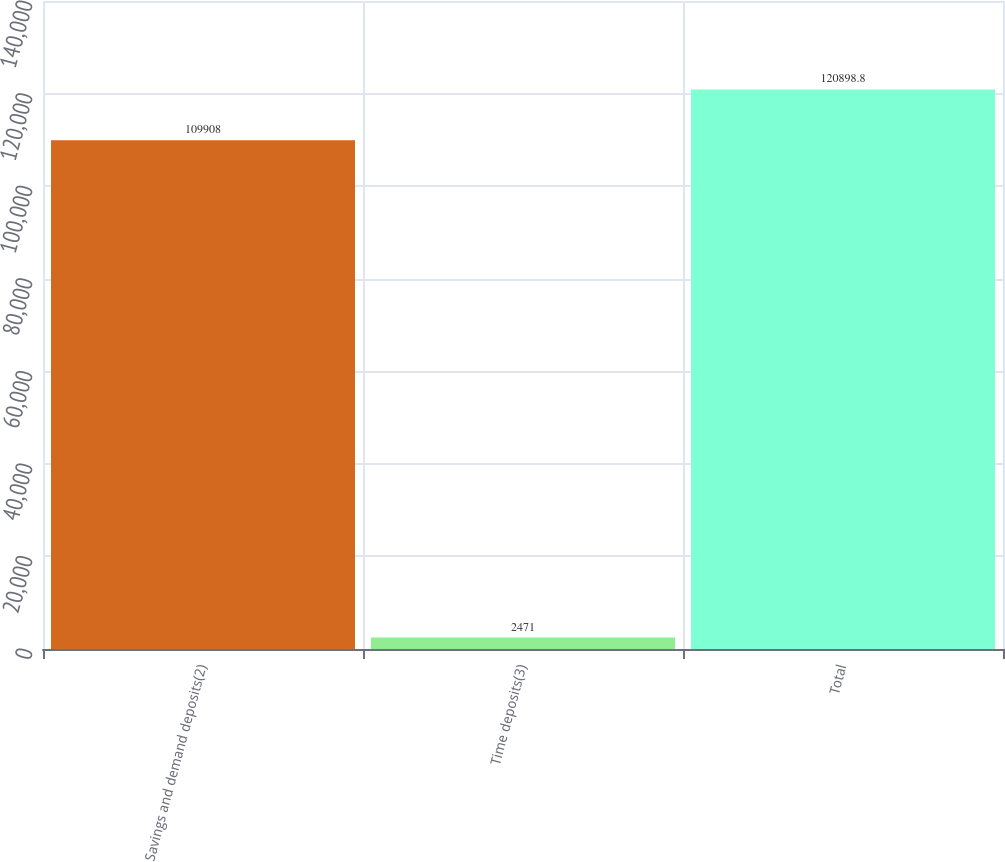Convert chart. <chart><loc_0><loc_0><loc_500><loc_500><bar_chart><fcel>Savings and demand deposits(2)<fcel>Time deposits(3)<fcel>Total<nl><fcel>109908<fcel>2471<fcel>120899<nl></chart> 